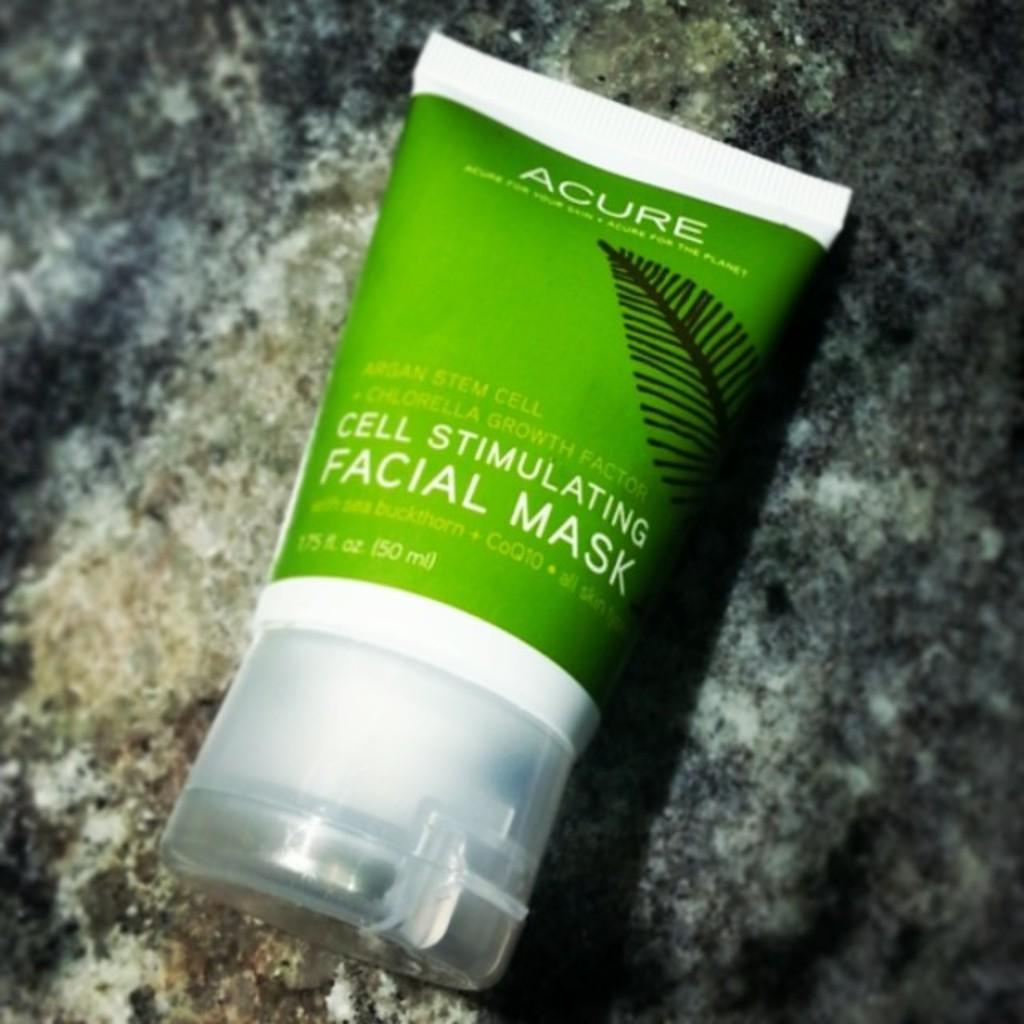Please provide a concise description of this image. In this picture there is a cosmetic tube. On the tube there is a picture of a leaf and there is text. 